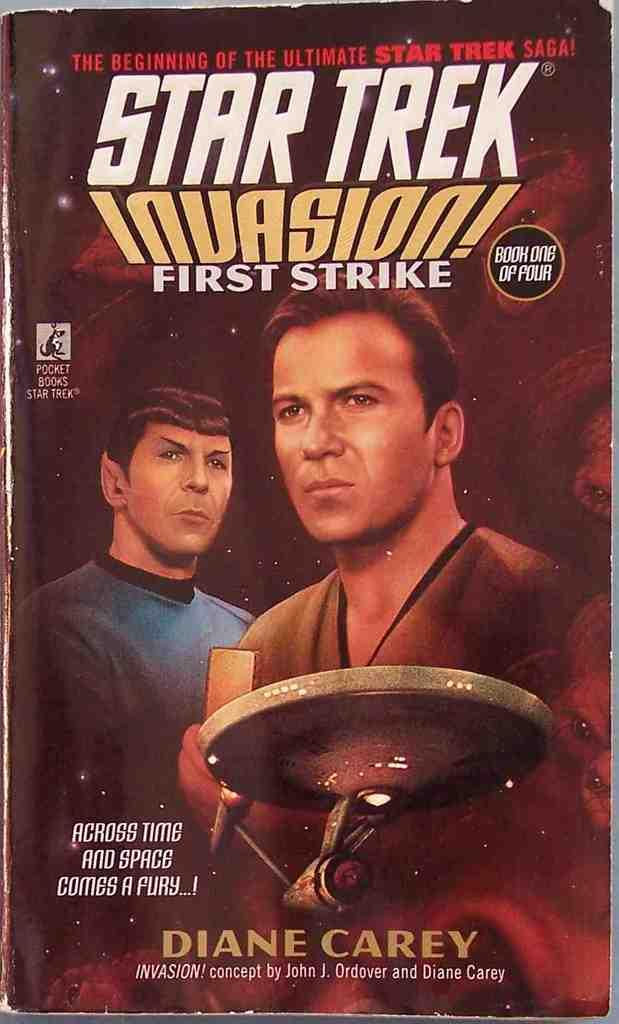<image>
Provide a brief description of the given image. The book Star Trek Invasion is written by Diane Carey. 